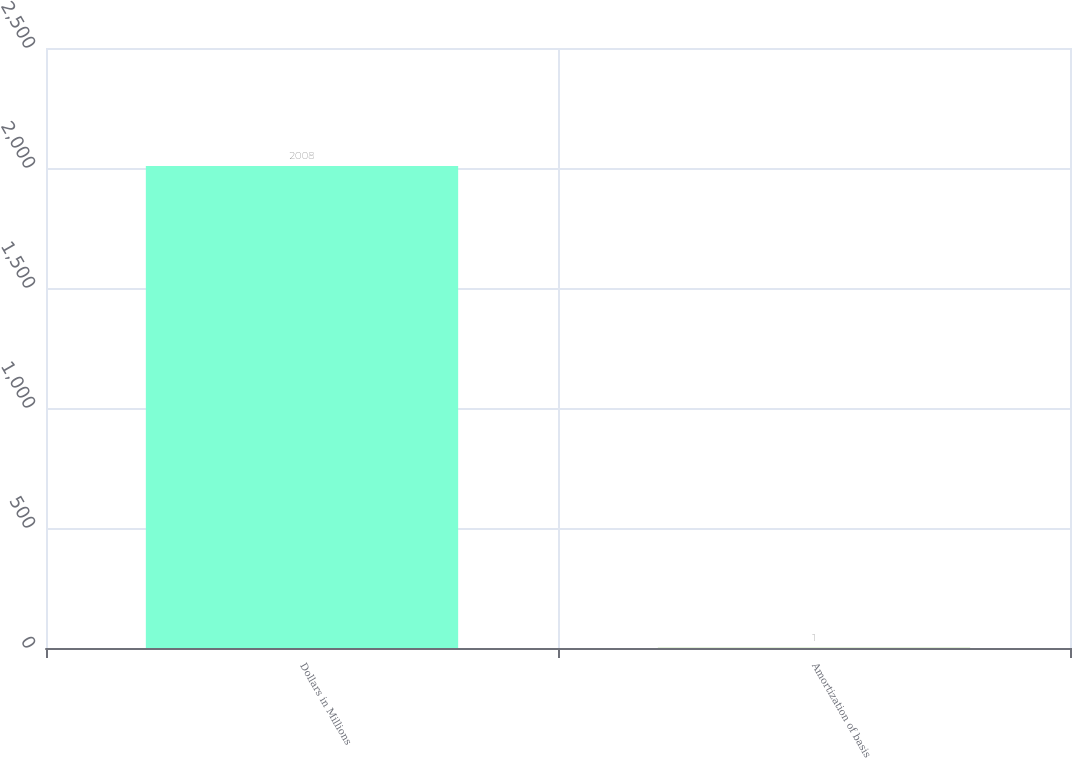<chart> <loc_0><loc_0><loc_500><loc_500><bar_chart><fcel>Dollars in Millions<fcel>Amortization of basis<nl><fcel>2008<fcel>1<nl></chart> 